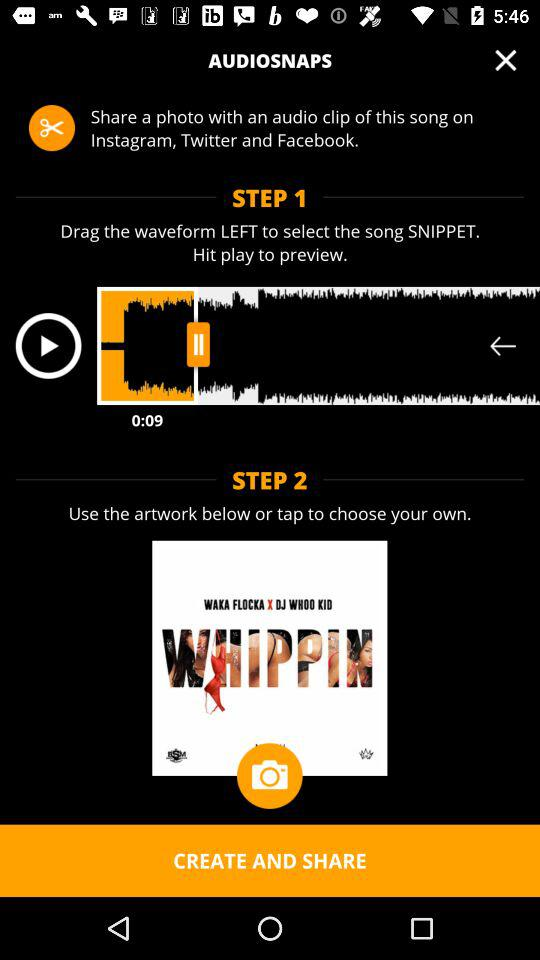How many steps are there to create an audio snap?
Answer the question using a single word or phrase. 2 